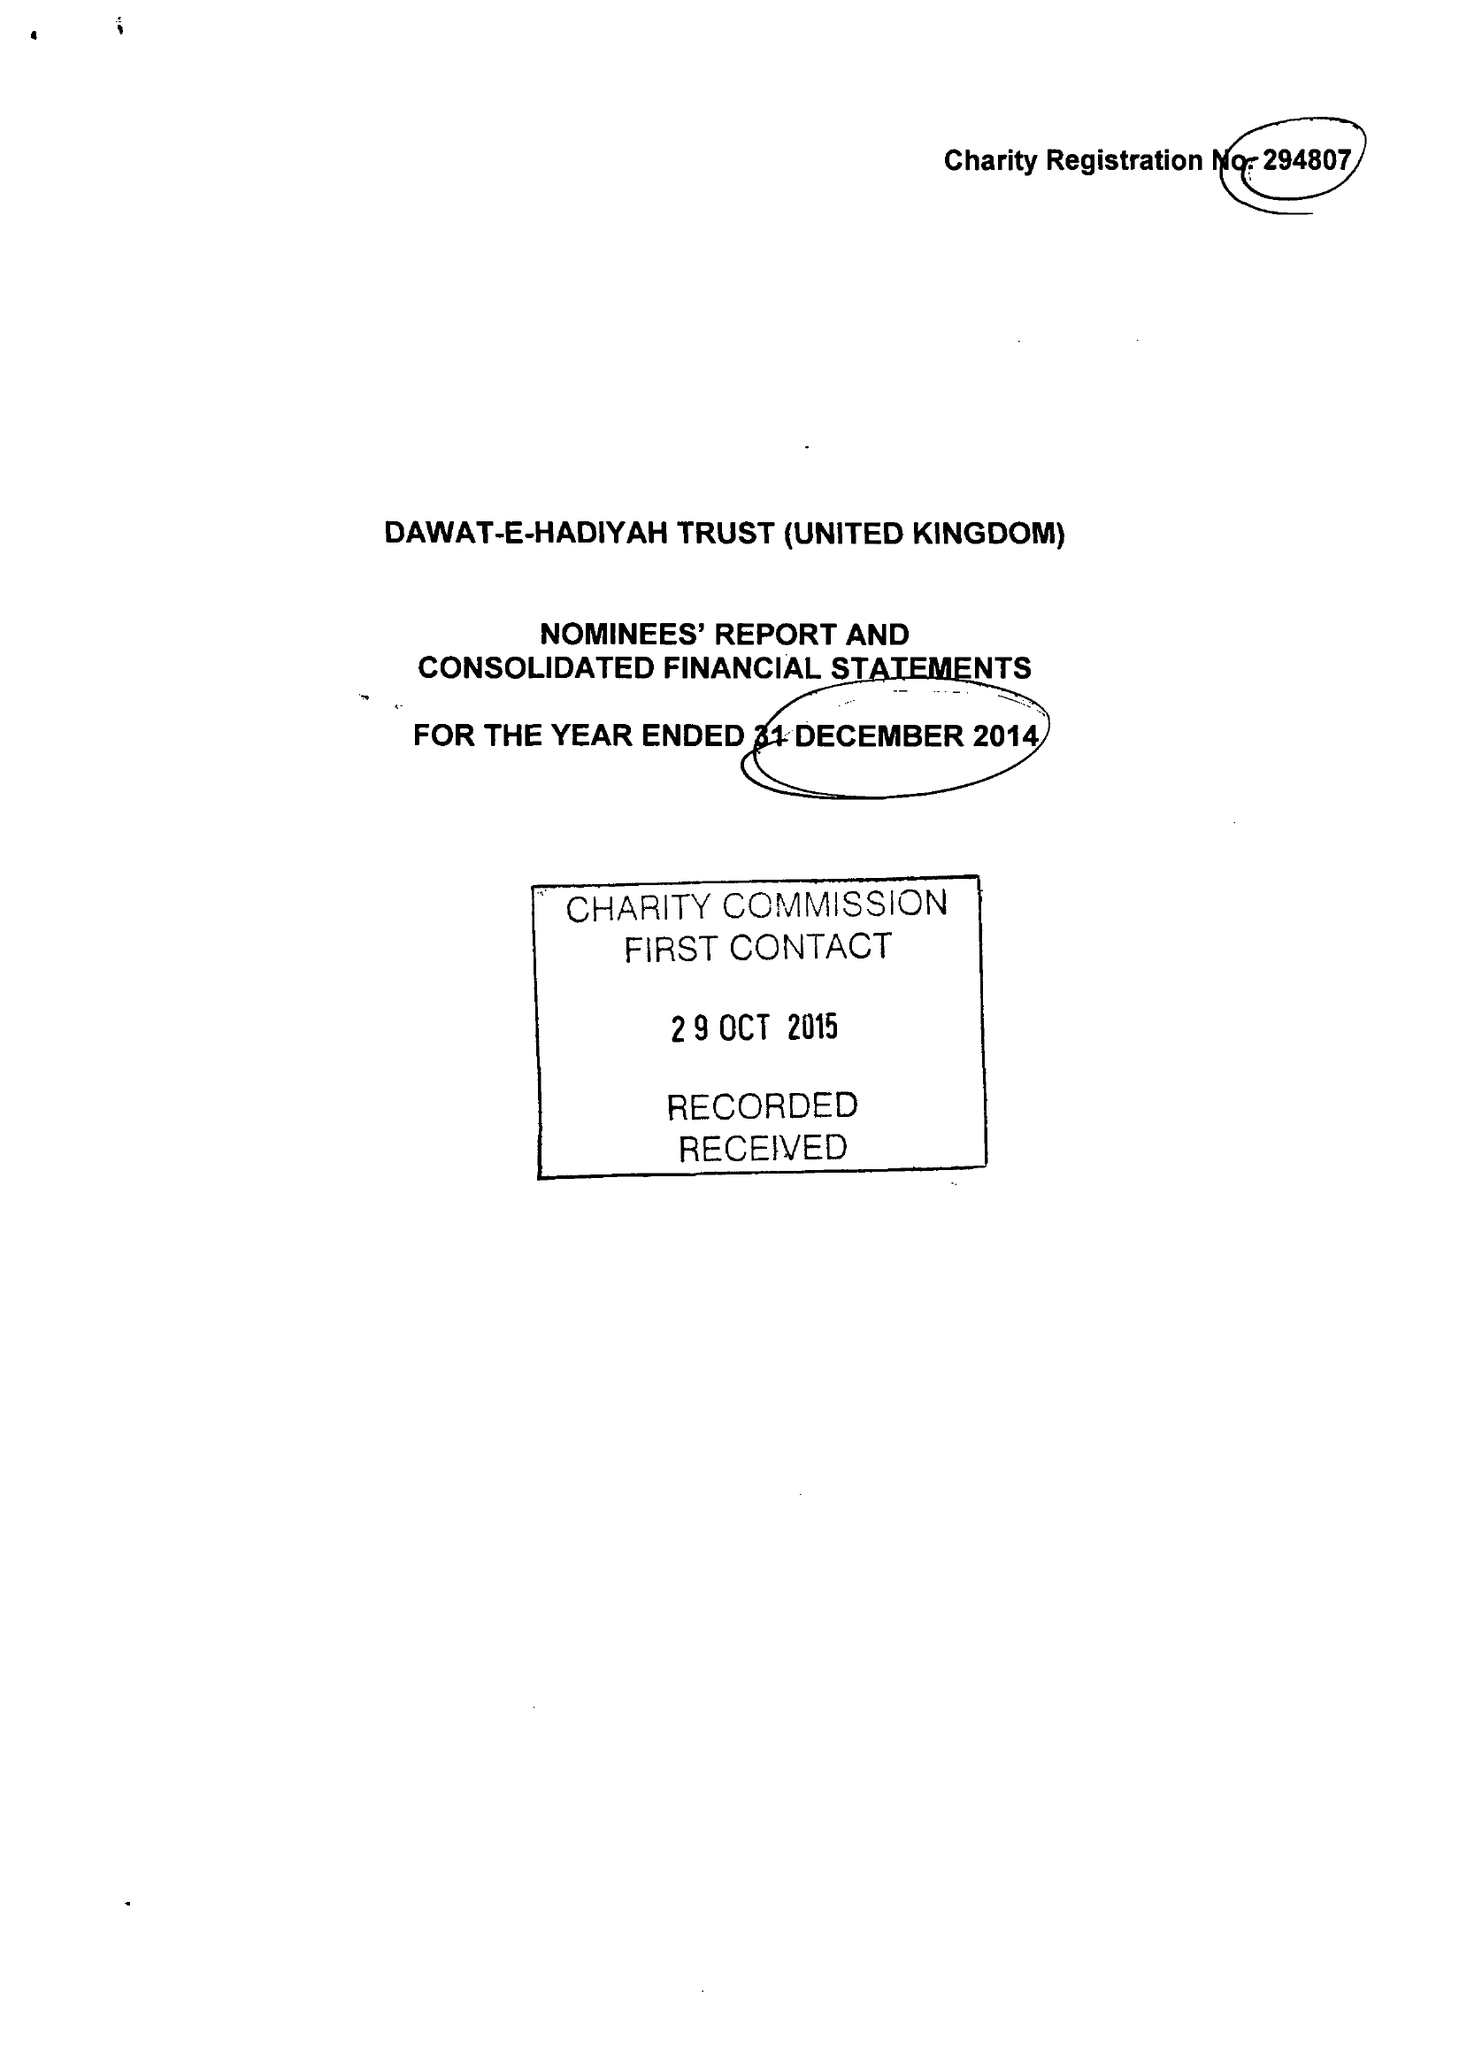What is the value for the charity_number?
Answer the question using a single word or phrase. 294807 